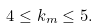<formula> <loc_0><loc_0><loc_500><loc_500>4 \leq k _ { m } \leq 5 .</formula> 